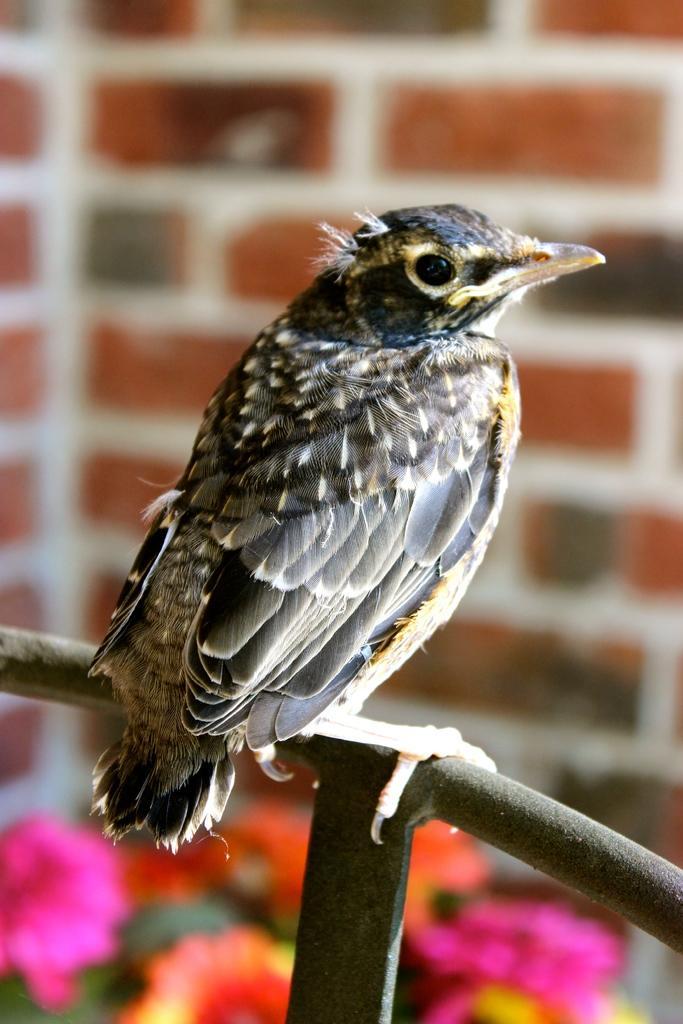Please provide a concise description of this image. In this image, we can see a bird on the rod. In the background, image is blurred. 